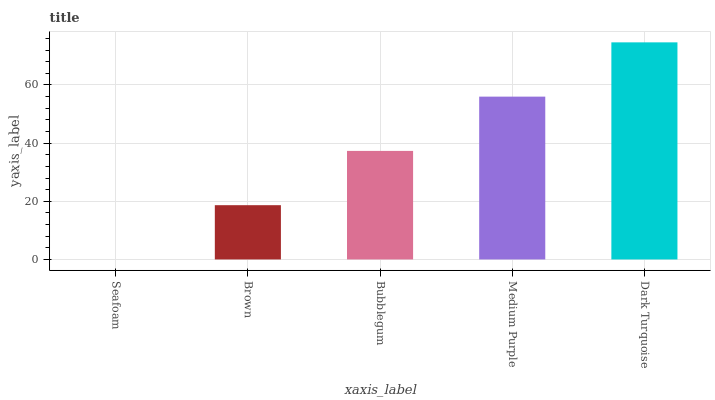Is Seafoam the minimum?
Answer yes or no. Yes. Is Dark Turquoise the maximum?
Answer yes or no. Yes. Is Brown the minimum?
Answer yes or no. No. Is Brown the maximum?
Answer yes or no. No. Is Brown greater than Seafoam?
Answer yes or no. Yes. Is Seafoam less than Brown?
Answer yes or no. Yes. Is Seafoam greater than Brown?
Answer yes or no. No. Is Brown less than Seafoam?
Answer yes or no. No. Is Bubblegum the high median?
Answer yes or no. Yes. Is Bubblegum the low median?
Answer yes or no. Yes. Is Dark Turquoise the high median?
Answer yes or no. No. Is Dark Turquoise the low median?
Answer yes or no. No. 